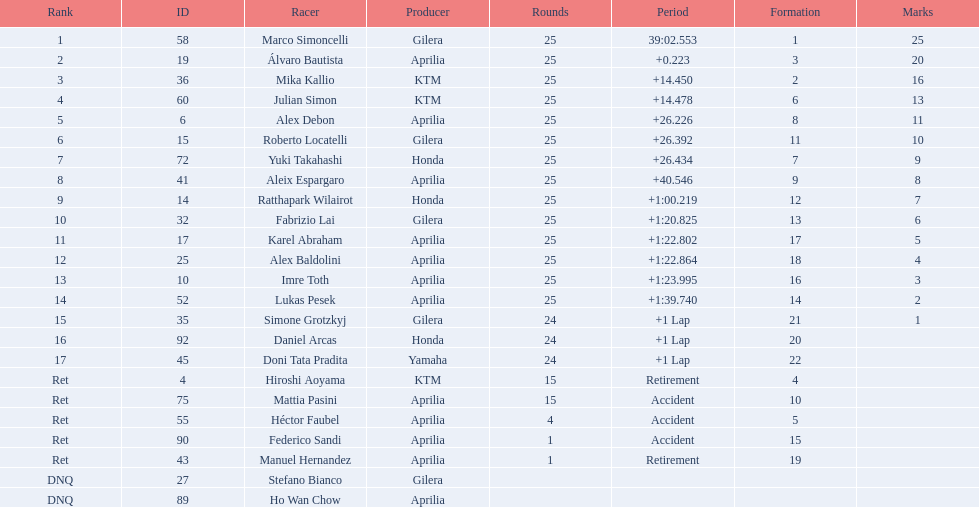What was the fastest overall time? 39:02.553. Parse the full table in json format. {'header': ['Rank', 'ID', 'Racer', 'Producer', 'Rounds', 'Period', 'Formation', 'Marks'], 'rows': [['1', '58', 'Marco Simoncelli', 'Gilera', '25', '39:02.553', '1', '25'], ['2', '19', 'Álvaro Bautista', 'Aprilia', '25', '+0.223', '3', '20'], ['3', '36', 'Mika Kallio', 'KTM', '25', '+14.450', '2', '16'], ['4', '60', 'Julian Simon', 'KTM', '25', '+14.478', '6', '13'], ['5', '6', 'Alex Debon', 'Aprilia', '25', '+26.226', '8', '11'], ['6', '15', 'Roberto Locatelli', 'Gilera', '25', '+26.392', '11', '10'], ['7', '72', 'Yuki Takahashi', 'Honda', '25', '+26.434', '7', '9'], ['8', '41', 'Aleix Espargaro', 'Aprilia', '25', '+40.546', '9', '8'], ['9', '14', 'Ratthapark Wilairot', 'Honda', '25', '+1:00.219', '12', '7'], ['10', '32', 'Fabrizio Lai', 'Gilera', '25', '+1:20.825', '13', '6'], ['11', '17', 'Karel Abraham', 'Aprilia', '25', '+1:22.802', '17', '5'], ['12', '25', 'Alex Baldolini', 'Aprilia', '25', '+1:22.864', '18', '4'], ['13', '10', 'Imre Toth', 'Aprilia', '25', '+1:23.995', '16', '3'], ['14', '52', 'Lukas Pesek', 'Aprilia', '25', '+1:39.740', '14', '2'], ['15', '35', 'Simone Grotzkyj', 'Gilera', '24', '+1 Lap', '21', '1'], ['16', '92', 'Daniel Arcas', 'Honda', '24', '+1 Lap', '20', ''], ['17', '45', 'Doni Tata Pradita', 'Yamaha', '24', '+1 Lap', '22', ''], ['Ret', '4', 'Hiroshi Aoyama', 'KTM', '15', 'Retirement', '4', ''], ['Ret', '75', 'Mattia Pasini', 'Aprilia', '15', 'Accident', '10', ''], ['Ret', '55', 'Héctor Faubel', 'Aprilia', '4', 'Accident', '5', ''], ['Ret', '90', 'Federico Sandi', 'Aprilia', '1', 'Accident', '15', ''], ['Ret', '43', 'Manuel Hernandez', 'Aprilia', '1', 'Retirement', '19', ''], ['DNQ', '27', 'Stefano Bianco', 'Gilera', '', '', '', ''], ['DNQ', '89', 'Ho Wan Chow', 'Aprilia', '', '', '', '']]} Who does this time belong to? Marco Simoncelli. 